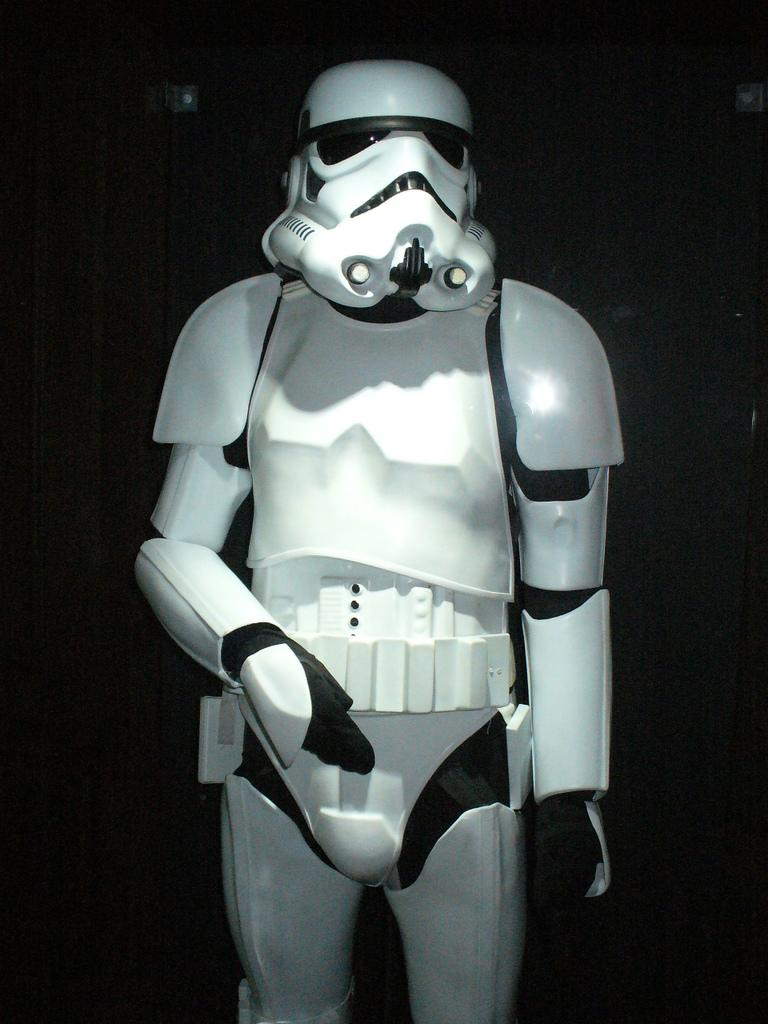What character can be seen in the image? There is a stormtrooper in the image. What is the color of the background in the image? The background of the image is dark. How many houses can be seen in the image? There are no houses present in the image. What type of sail is visible in the image? There is no sail present in the image. 